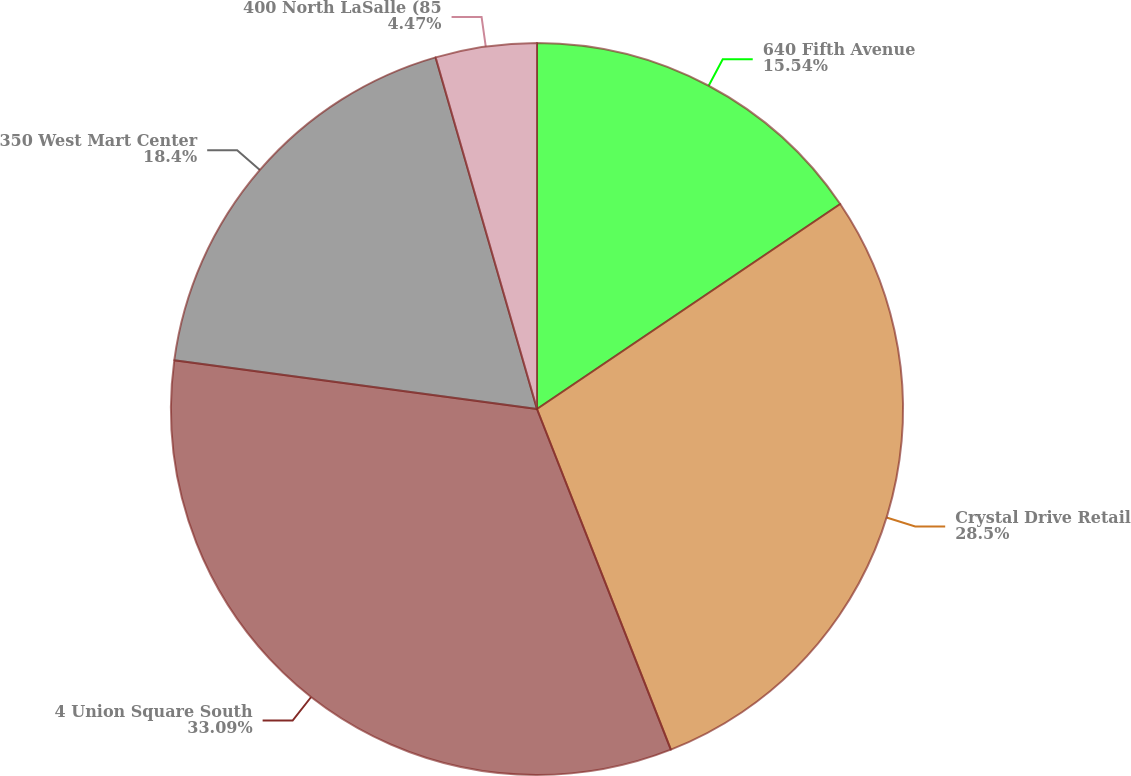<chart> <loc_0><loc_0><loc_500><loc_500><pie_chart><fcel>640 Fifth Avenue<fcel>Crystal Drive Retail<fcel>4 Union Square South<fcel>350 West Mart Center<fcel>400 North LaSalle (85<nl><fcel>15.54%<fcel>28.5%<fcel>33.09%<fcel>18.4%<fcel>4.47%<nl></chart> 